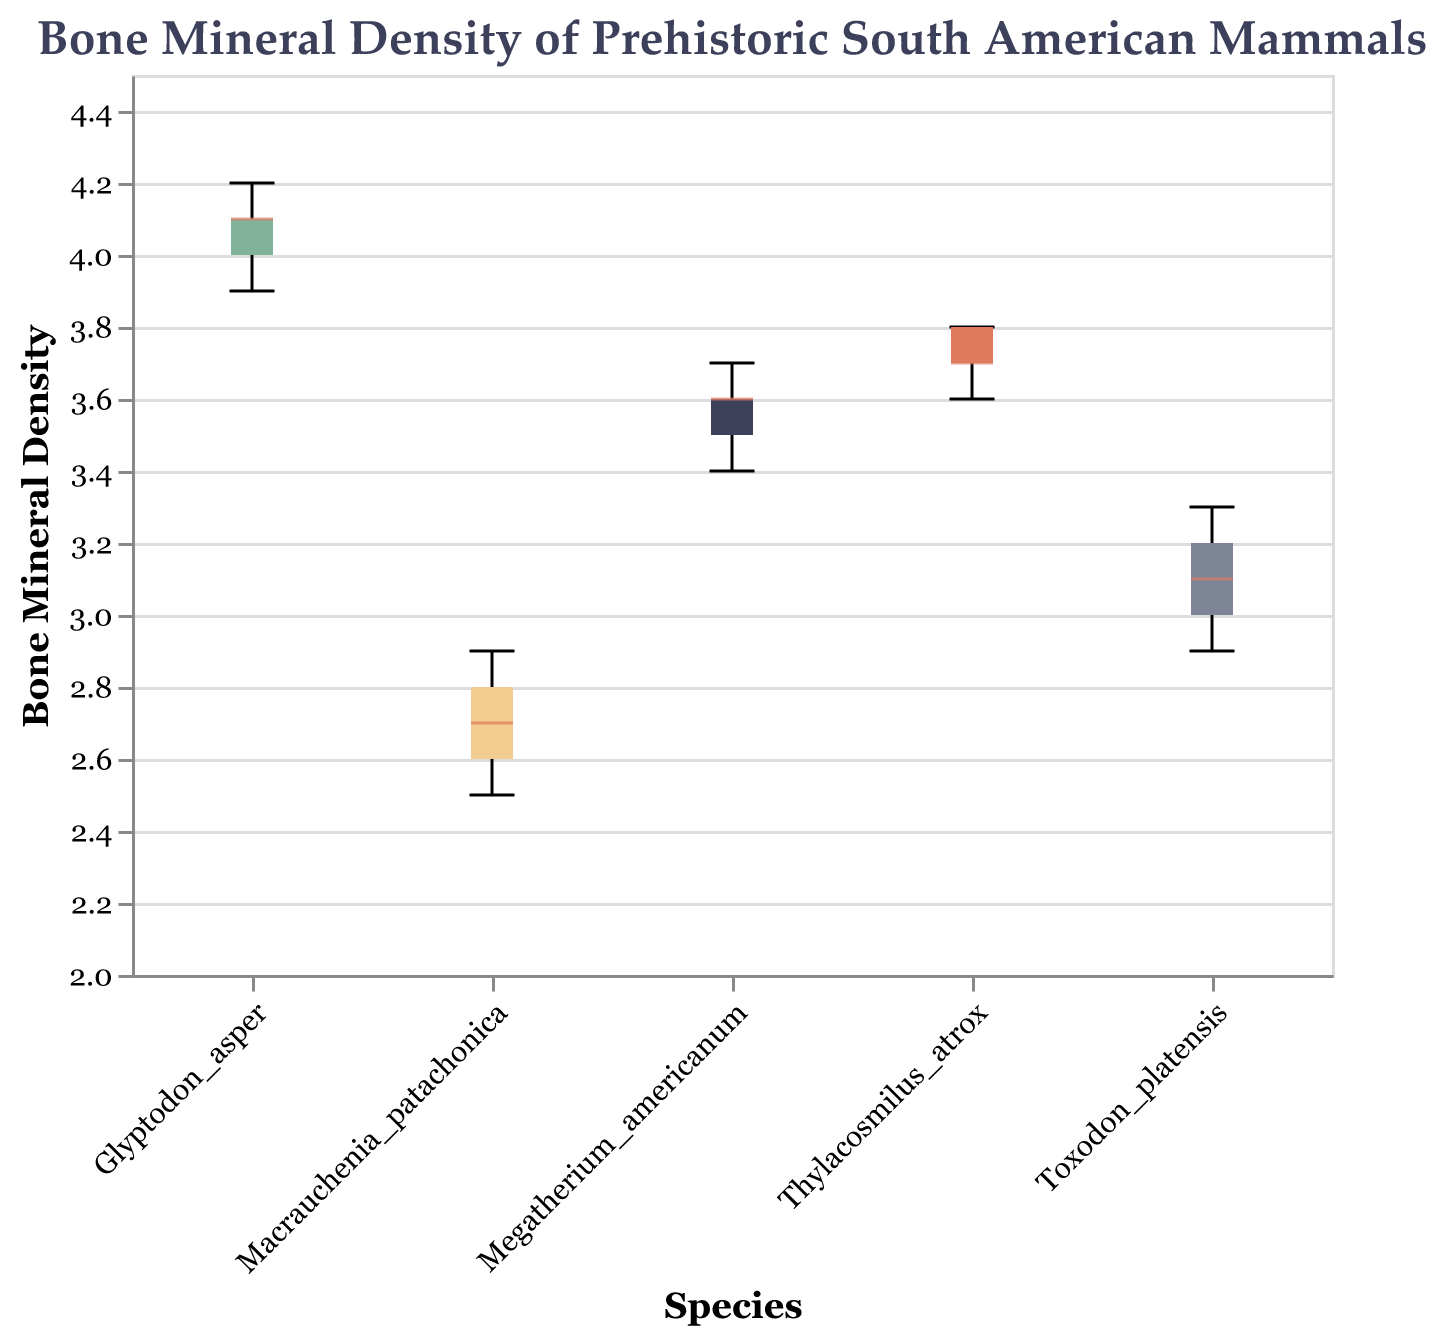What is the title of the figure? The title is prominently displayed at the very top of the figure in a larger font size, indicating what the overall data is about.
Answer: Bone Mineral Density of Prehistoric South American Mammals What species has the highest median bone mineral density? By examining the middle line in each boxplot, which represents the median, we can compare these lines across the species. The species with the highest median line has the highest median bone mineral density.
Answer: Glyptodon asper Which species has the widest range of bone mineral density values? The range is indicated by the distance from the top to the bottom whiskers in each boxplot. The species with the largest distance between these whiskers has the widest range.
Answer: Glyptodon asper What is the median bone mineral density for Thylacosmilus atrox? The median value is represented by the central line within the boxplot for this species.
Answer: 3.7 How does the interquartile range (IQR) of Macrauchenia patachonica compare to that of Toxodon platensis? The IQR is the difference between the first quartile (bottom of the box) and the third quartile (top of the box). By visually comparing the height of the boxes for these two species, we can see which box is taller.
Answer: The IQR of Macrauchenia patachonica is smaller than that of Toxodon platensis Which species has the smallest variability in bone mineral density? Variability in a boxplot is shown by the overall length of the whiskers and the spread of the box. The species with the shortest whiskers and narrowest box has the smallest variability.
Answer: Thylacosmilus atrox How does the median bone mineral density of Megatherium americanum compare to that of Toxodon platensis? The middle line of the boxplots for these two species needs to be compared to see which median is higher.
Answer: The median bone mineral density for Megatherium americanum is slightly lower than that for Toxodon platensis What is the bone mineral density value at the 75th percentile for Glyptodon asper? The 75th percentile corresponds to the upper edge of the boxes in the boxplot. For Glyptodon asper, this value can be located by viewing the top of this species' box.
Answer: 4.1 What species shows the most outliers if any? Outliers in a boxplot are marked beyond the whiskers typically as individual points. By scanning for such points beyond whiskers across species, we can see if any are present.
Answer: None Which species has a bone mineral density value at the 25th percentile equal to the maximum bone mineral density value for Macrauchenia patachonica? The 25th percentile value can be observed at the bottom edge of the box, and this value should be compared across all species with the maximum value of Macrauchenia patachonica, noted at the top whisker of that species' boxplot.
Answer: Toxodon platensis 